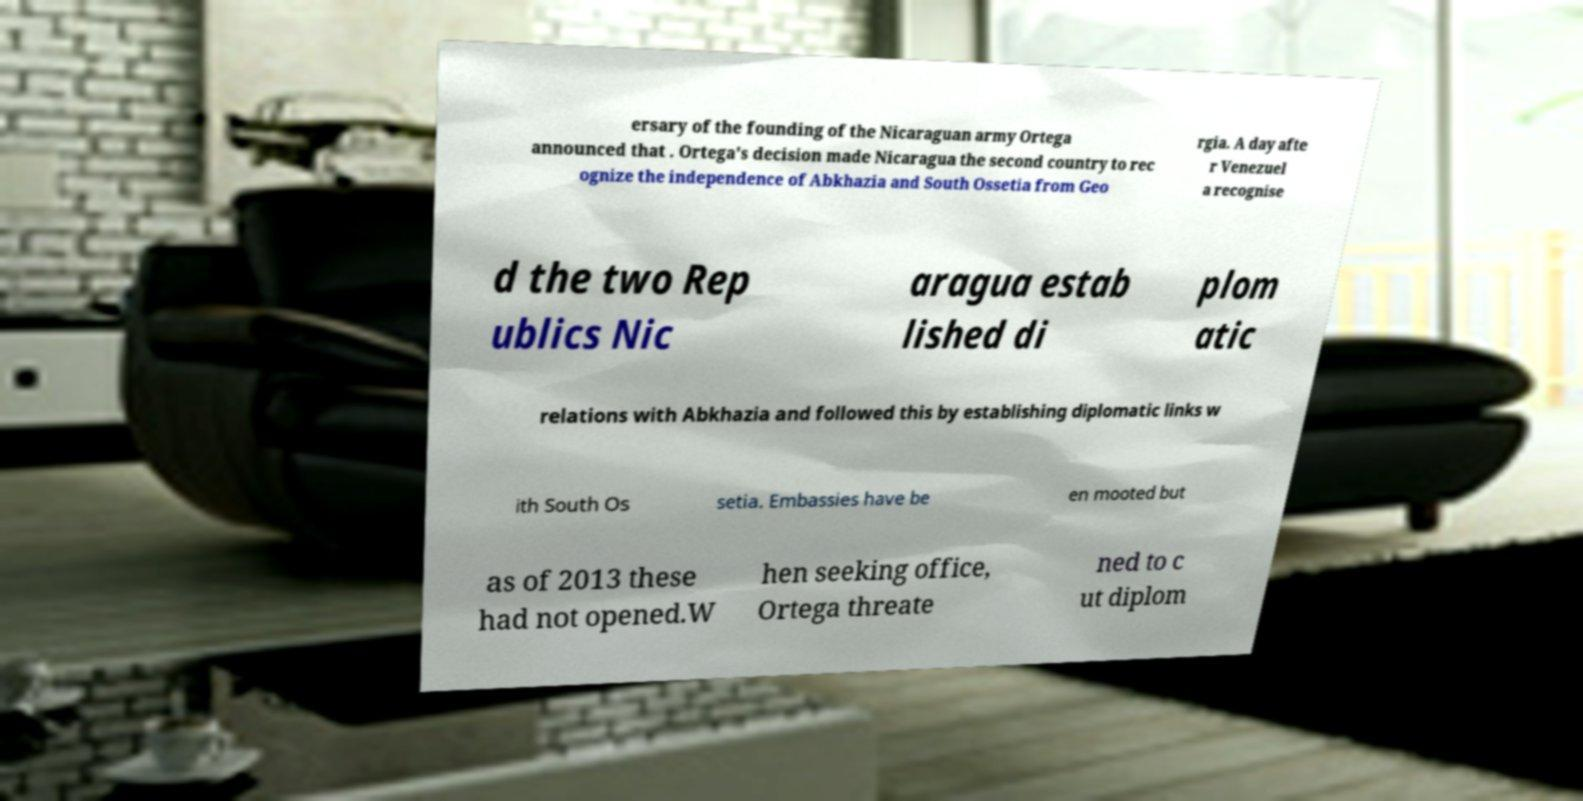I need the written content from this picture converted into text. Can you do that? ersary of the founding of the Nicaraguan army Ortega announced that . Ortega's decision made Nicaragua the second country to rec ognize the independence of Abkhazia and South Ossetia from Geo rgia. A day afte r Venezuel a recognise d the two Rep ublics Nic aragua estab lished di plom atic relations with Abkhazia and followed this by establishing diplomatic links w ith South Os setia. Embassies have be en mooted but as of 2013 these had not opened.W hen seeking office, Ortega threate ned to c ut diplom 